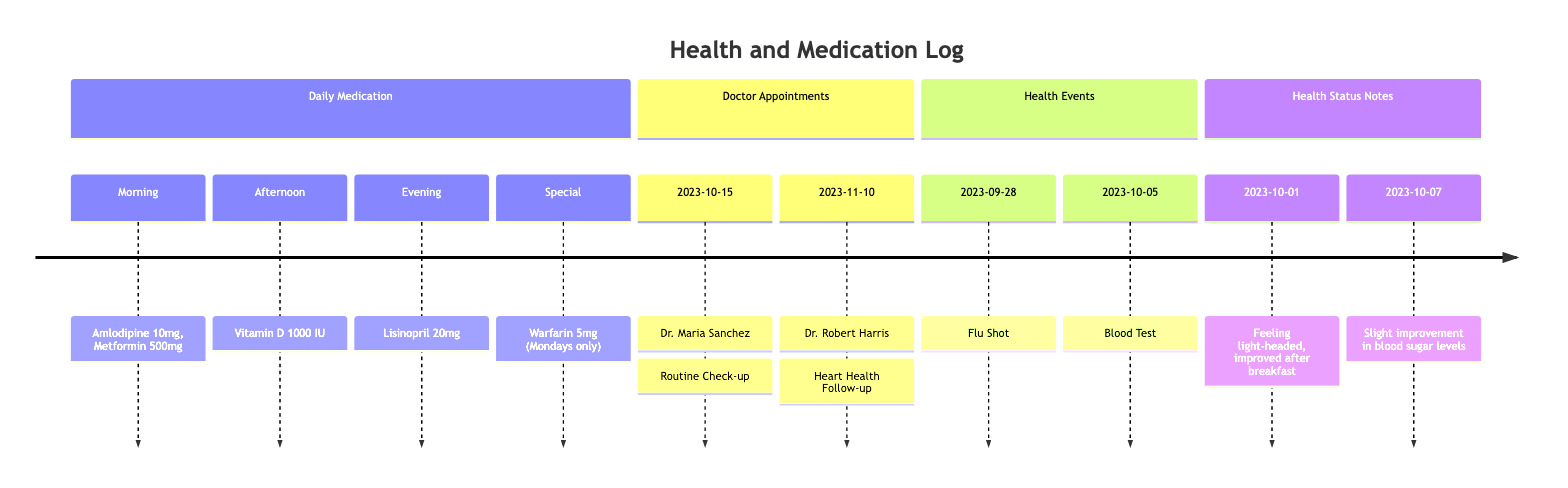What medications are taken in the morning? The timeline section for Daily Medication lists the medications for each time of day. Under Morning, the medications listed are Amlodipine 10mg and Metformin 500mg.
Answer: Amlodipine 10mg, Metformin 500mg What is the date of the next doctor appointment? Looking at the Doctor Appointments section, the next appointment after today's date is with Dr. Robert Harris on November 10, 2023.
Answer: 2023-11-10 How many health status notes are recorded? In the Health Status Notes section, there are two entries dated October 1 and October 7. Counting these entries gives the total number of notes.
Answer: 2 What was the significant health event on October 5? The timeline details that on October 5, a Blood Test was recorded in the Health Events section. This can be found by examining the entries listed there.
Answer: Blood Test Which medication is taken on Mondays only? Looking at the Daily Medication section for Special medications, it states that Warfarin 5mg is taken, specifically on Mondays.
Answer: Warfarin 5mg What was noted on October 1 about the patient's condition? In the Health Status Notes section, the note dated October 1 mentions feeling light-headed in the morning and improvement after breakfast. This gives insight into the condition on that date.
Answer: Feeling light-headed, improved after breakfast Who is the doctor for the routine check-up? From the Doctor Appointments section, the entry for the routine check-up on October 15 indicates that the doctor is Dr. Maria Sanchez.
Answer: Dr. Maria Sanchez What type of health event took place on September 28? According to the Health Events section, the significant health event on September 28 is a Flu Shot. This is directly listed under that section.
Answer: Flu Shot 